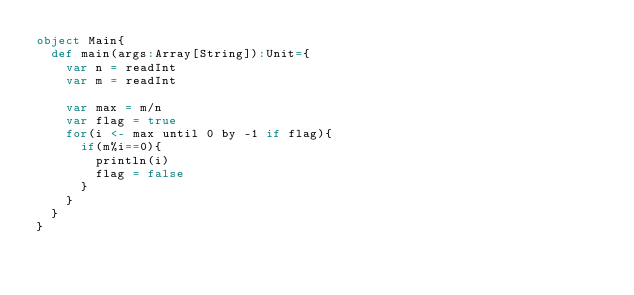<code> <loc_0><loc_0><loc_500><loc_500><_Scala_>object Main{
  def main(args:Array[String]):Unit={
    var n = readInt
    var m = readInt
    
    var max = m/n
    var flag = true
    for(i <- max until 0 by -1 if flag){
      if(m%i==0){
        println(i)
        flag = false
      }
    }
  }
}</code> 